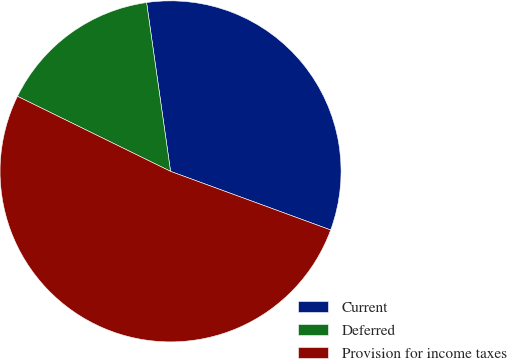Convert chart. <chart><loc_0><loc_0><loc_500><loc_500><pie_chart><fcel>Current<fcel>Deferred<fcel>Provision for income taxes<nl><fcel>32.83%<fcel>15.5%<fcel>51.67%<nl></chart> 